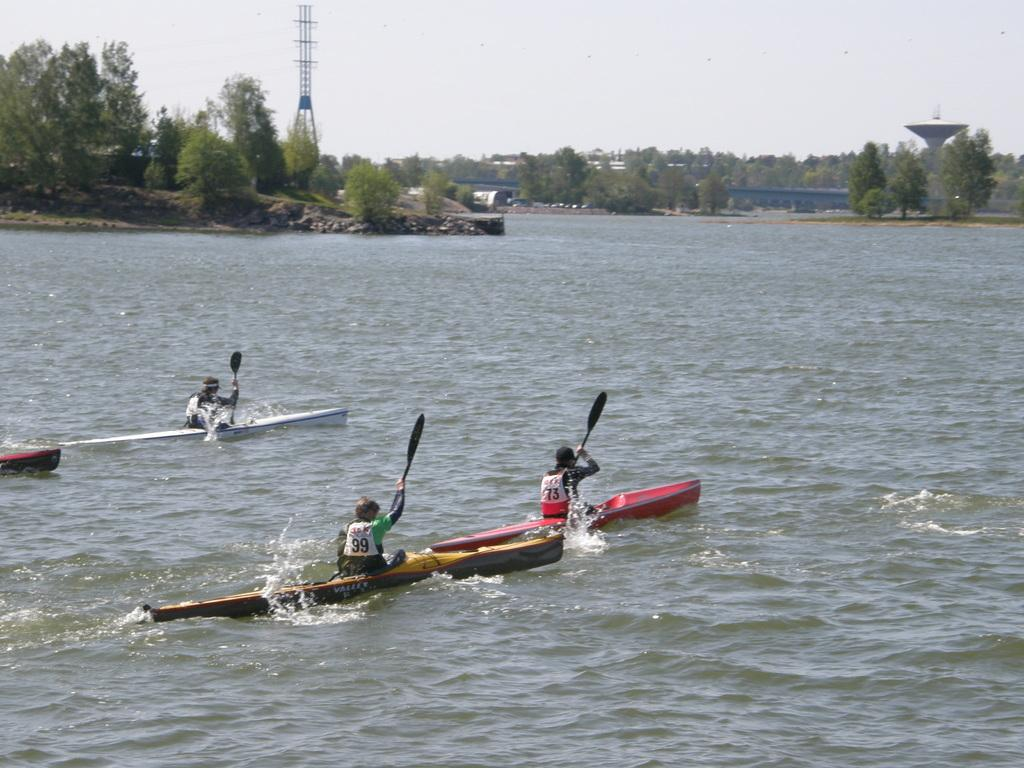How many people are in the image? There are three persons in the image. What are the persons holding in their hands? The persons are holding paddles. What activity are the persons engaged in? The persons are rowing boats on the water. What structures can be seen in the image? There are towers in the image. What type of vegetation is present in the image? There are trees in the image. What is visible in the background of the image? The sky is visible in the background of the image. How many doors are visible on the boats in the image? There are no doors visible on the boats in the image, as boats typically do not have doors. 